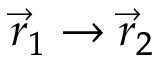<formula> <loc_0><loc_0><loc_500><loc_500>{ \vec { r } _ { 1 } \to \vec { r } _ { 2 } }</formula> 